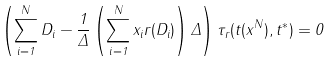Convert formula to latex. <formula><loc_0><loc_0><loc_500><loc_500>\left ( \sum _ { i = 1 } ^ { N } D _ { i } - \frac { 1 } { \Delta } \left ( \sum _ { i = 1 } ^ { N } x _ { i } r ( D _ { i } ) \right ) { \Delta } \right ) \tau _ { r } ( { t } ( { x } ^ { N } ) , { t } ^ { * } ) = 0</formula> 